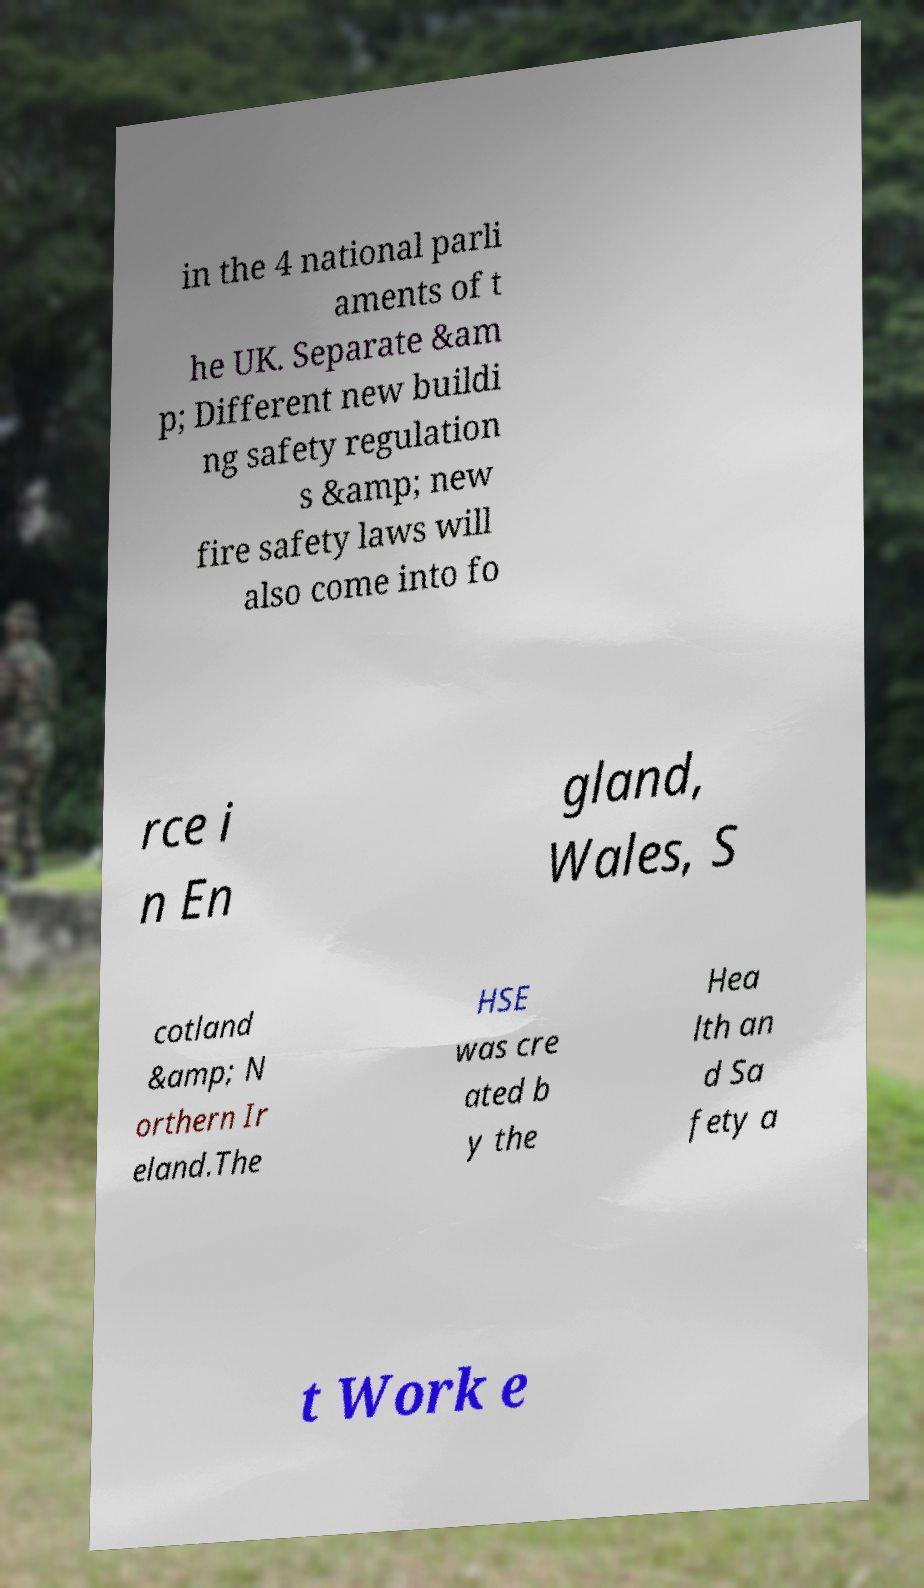Can you accurately transcribe the text from the provided image for me? in the 4 national parli aments of t he UK. Separate &am p; Different new buildi ng safety regulation s &amp; new fire safety laws will also come into fo rce i n En gland, Wales, S cotland &amp; N orthern Ir eland.The HSE was cre ated b y the Hea lth an d Sa fety a t Work e 